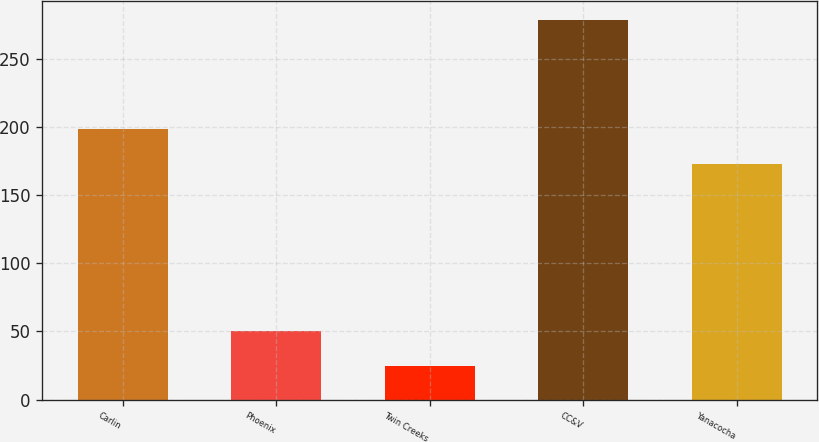Convert chart to OTSL. <chart><loc_0><loc_0><loc_500><loc_500><bar_chart><fcel>Carlin<fcel>Phoenix<fcel>Twin Creeks<fcel>CC&V<fcel>Yanacocha<nl><fcel>198.3<fcel>50.3<fcel>25<fcel>278<fcel>173<nl></chart> 